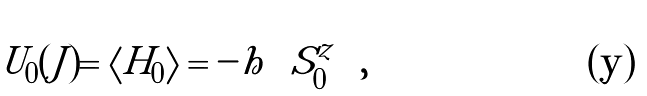Convert formula to latex. <formula><loc_0><loc_0><loc_500><loc_500>U _ { 0 } ( J ) = \left \langle H _ { 0 } \right \rangle = - h \left \langle S _ { 0 } ^ { z } \right \rangle ,</formula> 